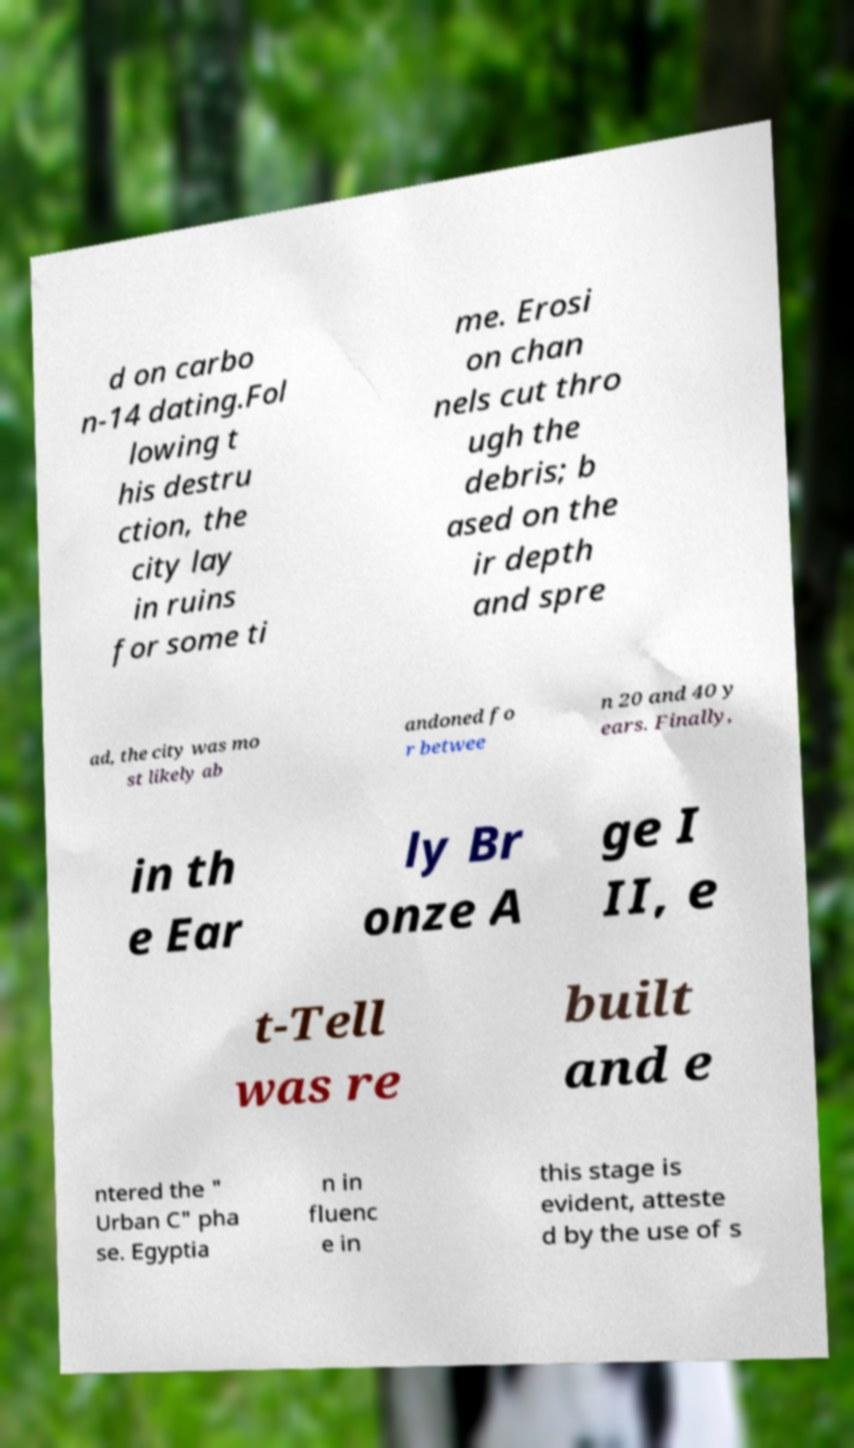There's text embedded in this image that I need extracted. Can you transcribe it verbatim? d on carbo n-14 dating.Fol lowing t his destru ction, the city lay in ruins for some ti me. Erosi on chan nels cut thro ugh the debris; b ased on the ir depth and spre ad, the city was mo st likely ab andoned fo r betwee n 20 and 40 y ears. Finally, in th e Ear ly Br onze A ge I II, e t-Tell was re built and e ntered the " Urban C" pha se. Egyptia n in fluenc e in this stage is evident, atteste d by the use of s 